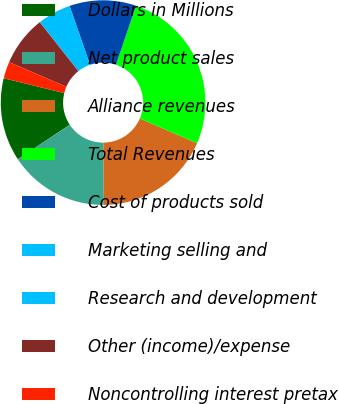Convert chart. <chart><loc_0><loc_0><loc_500><loc_500><pie_chart><fcel>Dollars in Millions<fcel>Net product sales<fcel>Alliance revenues<fcel>Total Revenues<fcel>Cost of products sold<fcel>Marketing selling and<fcel>Research and development<fcel>Other (income)/expense<fcel>Noncontrolling interest pretax<nl><fcel>13.15%<fcel>15.78%<fcel>18.4%<fcel>26.28%<fcel>10.53%<fcel>5.28%<fcel>0.03%<fcel>7.9%<fcel>2.65%<nl></chart> 